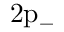<formula> <loc_0><loc_0><loc_500><loc_500>2 p _ { - }</formula> 